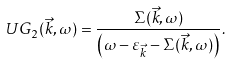Convert formula to latex. <formula><loc_0><loc_0><loc_500><loc_500>U G _ { 2 } ( \vec { k } , \omega ) = \frac { \Sigma ( \vec { k } , \omega ) } { \left ( \omega - \varepsilon _ { \vec { k } } - \Sigma ( \vec { k } , \omega ) \right ) } .</formula> 